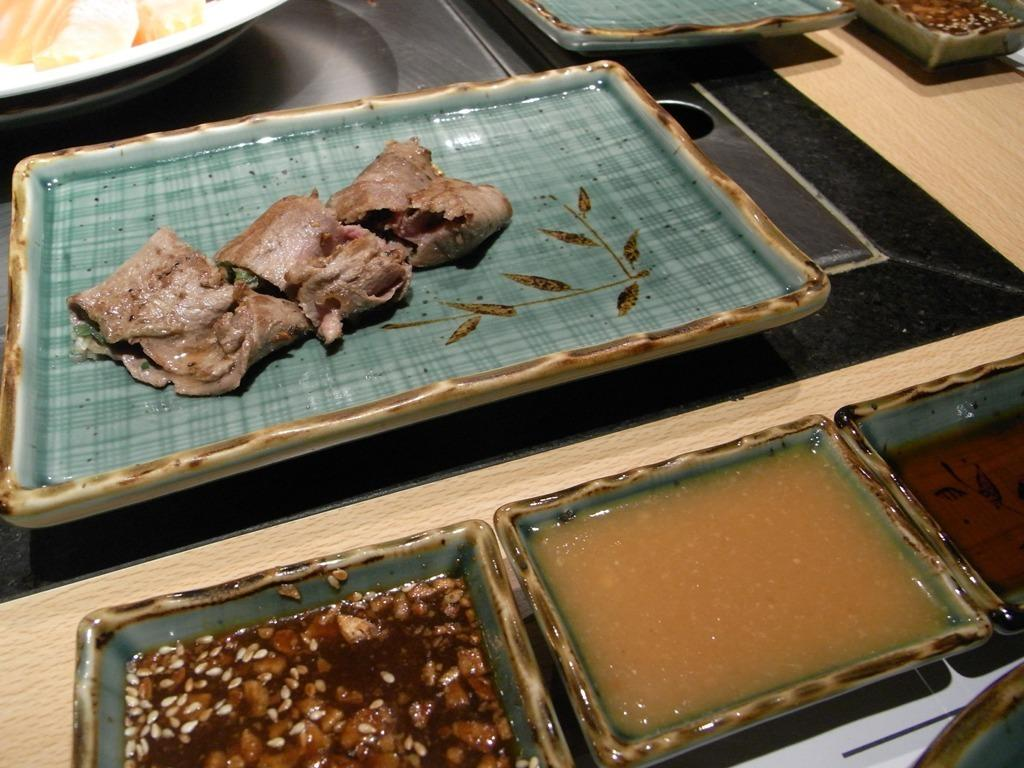What type of furniture is present in the image? There is a table in the image. What is placed on the table? There are serving plates with food and serving bowls with condiments on the table. What type of profit can be seen in the image? There is no mention of profit in the image; it features a table with food and condiments. 